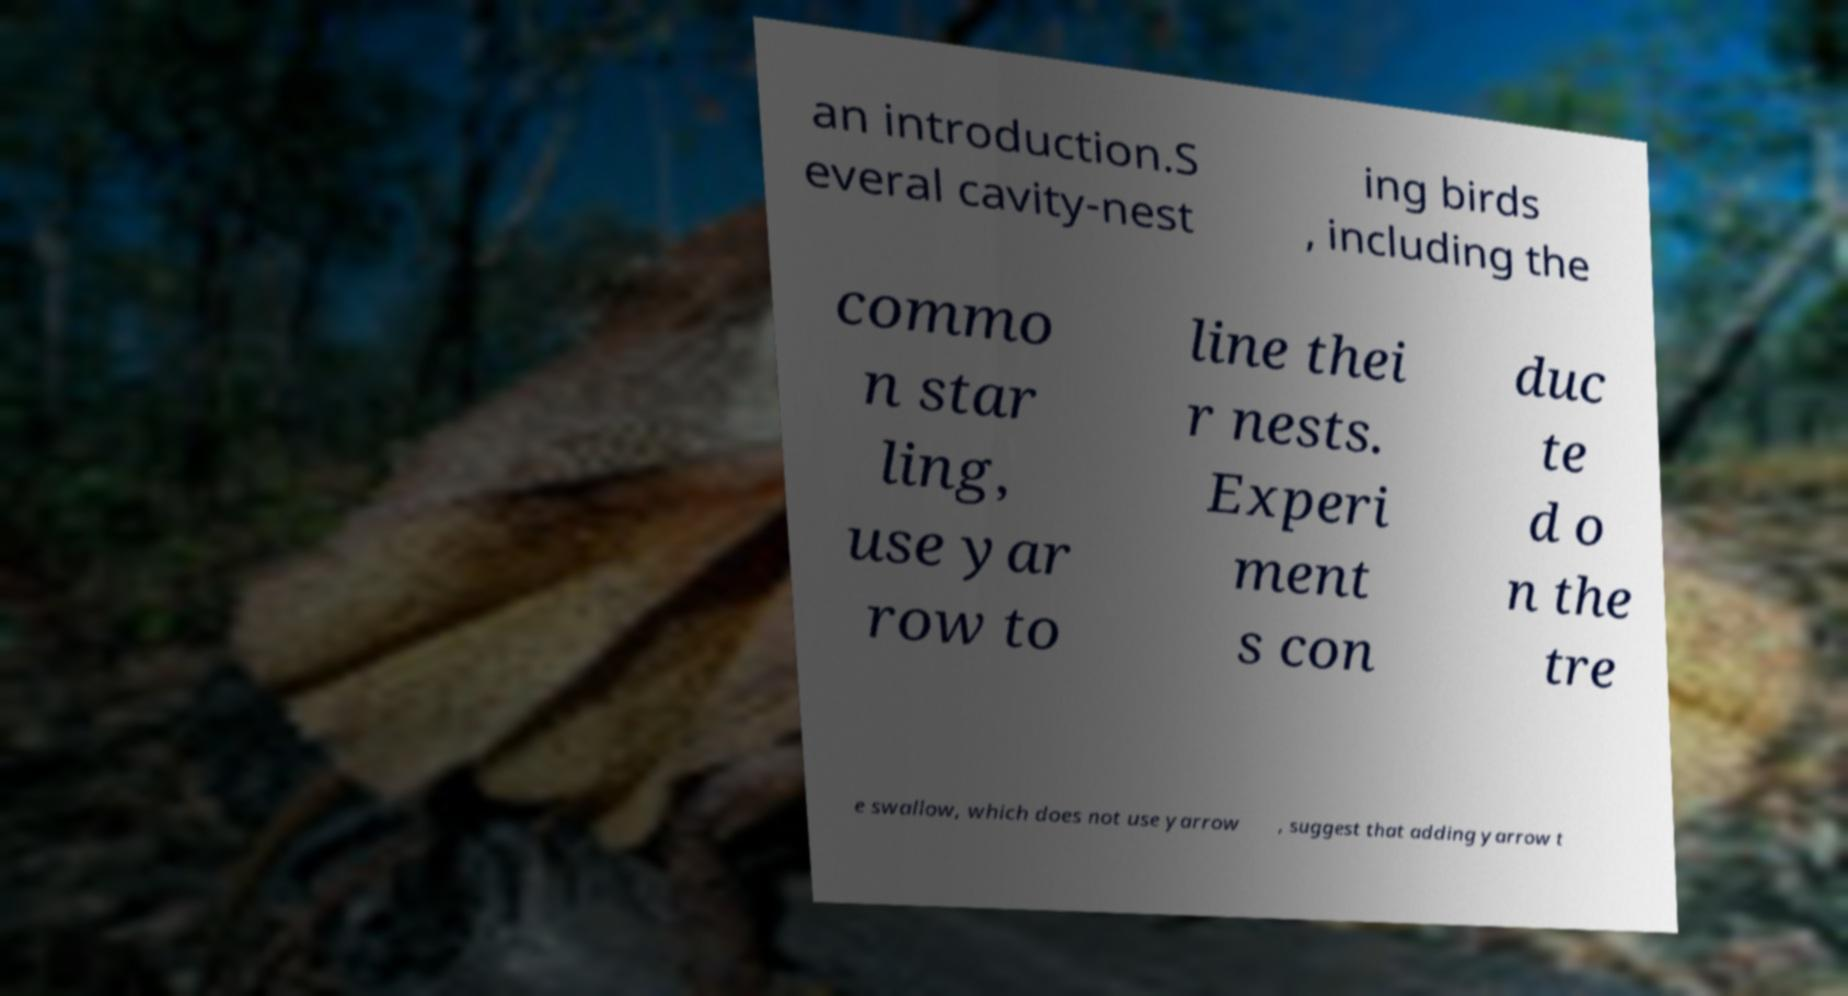Could you assist in decoding the text presented in this image and type it out clearly? an introduction.S everal cavity-nest ing birds , including the commo n star ling, use yar row to line thei r nests. Experi ment s con duc te d o n the tre e swallow, which does not use yarrow , suggest that adding yarrow t 